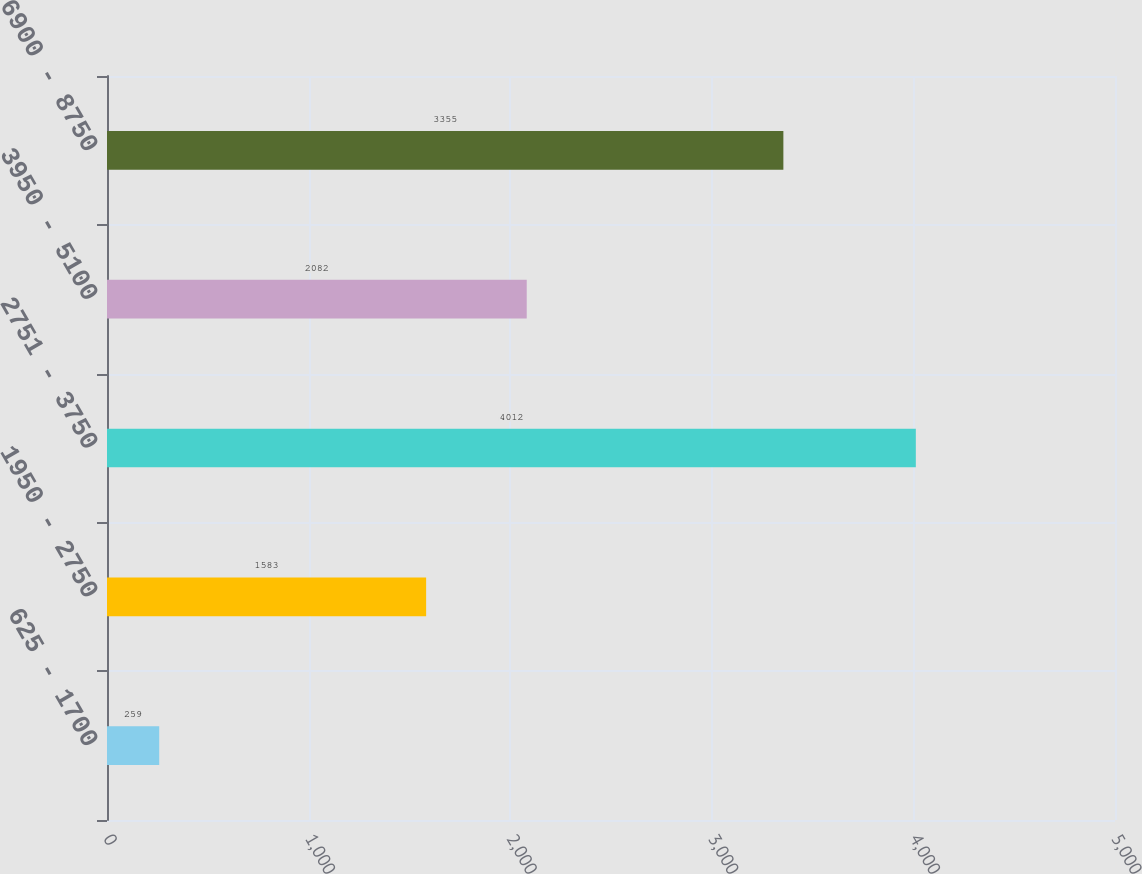Convert chart. <chart><loc_0><loc_0><loc_500><loc_500><bar_chart><fcel>625 - 1700<fcel>1950 - 2750<fcel>2751 - 3750<fcel>3950 - 5100<fcel>6900 - 8750<nl><fcel>259<fcel>1583<fcel>4012<fcel>2082<fcel>3355<nl></chart> 